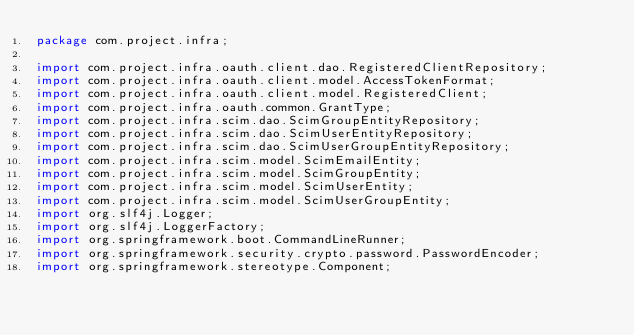Convert code to text. <code><loc_0><loc_0><loc_500><loc_500><_Java_>package com.project.infra;

import com.project.infra.oauth.client.dao.RegisteredClientRepository;
import com.project.infra.oauth.client.model.AccessTokenFormat;
import com.project.infra.oauth.client.model.RegisteredClient;
import com.project.infra.oauth.common.GrantType;
import com.project.infra.scim.dao.ScimGroupEntityRepository;
import com.project.infra.scim.dao.ScimUserEntityRepository;
import com.project.infra.scim.dao.ScimUserGroupEntityRepository;
import com.project.infra.scim.model.ScimEmailEntity;
import com.project.infra.scim.model.ScimGroupEntity;
import com.project.infra.scim.model.ScimUserEntity;
import com.project.infra.scim.model.ScimUserGroupEntity;
import org.slf4j.Logger;
import org.slf4j.LoggerFactory;
import org.springframework.boot.CommandLineRunner;
import org.springframework.security.crypto.password.PasswordEncoder;
import org.springframework.stereotype.Component;</code> 